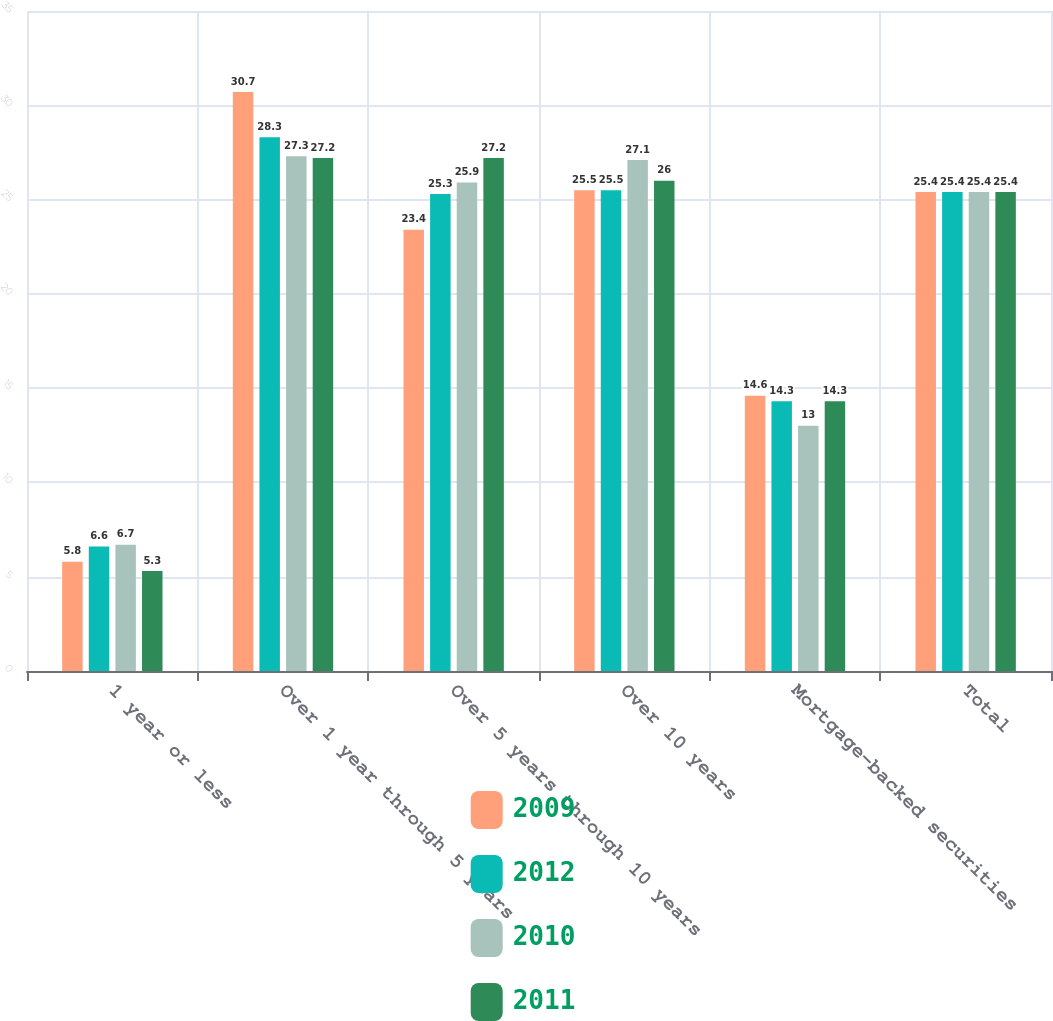Convert chart to OTSL. <chart><loc_0><loc_0><loc_500><loc_500><stacked_bar_chart><ecel><fcel>1 year or less<fcel>Over 1 year through 5 years<fcel>Over 5 years through 10 years<fcel>Over 10 years<fcel>Mortgage-backed securities<fcel>Total<nl><fcel>2009<fcel>5.8<fcel>30.7<fcel>23.4<fcel>25.5<fcel>14.6<fcel>25.4<nl><fcel>2012<fcel>6.6<fcel>28.3<fcel>25.3<fcel>25.5<fcel>14.3<fcel>25.4<nl><fcel>2010<fcel>6.7<fcel>27.3<fcel>25.9<fcel>27.1<fcel>13<fcel>25.4<nl><fcel>2011<fcel>5.3<fcel>27.2<fcel>27.2<fcel>26<fcel>14.3<fcel>25.4<nl></chart> 